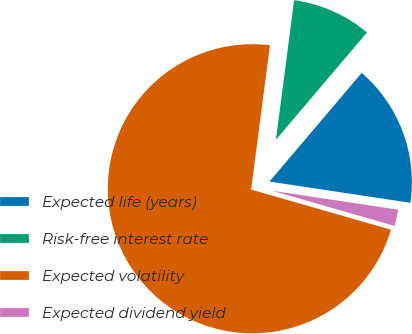Convert chart. <chart><loc_0><loc_0><loc_500><loc_500><pie_chart><fcel>Expected life (years)<fcel>Risk-free interest rate<fcel>Expected volatility<fcel>Expected dividend yield<nl><fcel>16.18%<fcel>9.13%<fcel>72.61%<fcel>2.07%<nl></chart> 